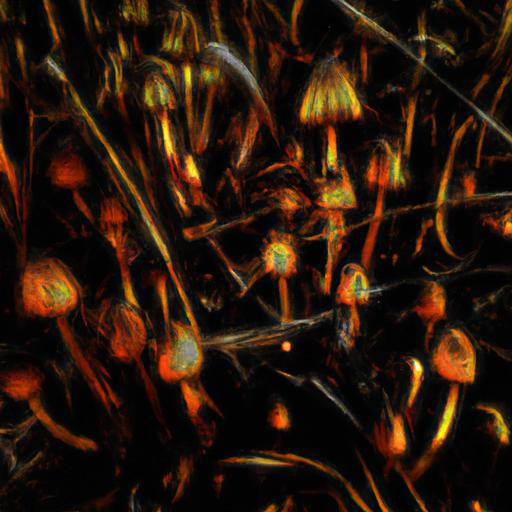Is the content of this image understandable? While the image might seem abstract at first glance, it actually appears to depict a stylized or artistically altered scene of nature, possibly including elements that resemble plant stems and mushroom-like figures glowing with an inner light against a dark background. The colors and textures suggest a vivid, organic setting, interpreted in a unique, artistic manner. 